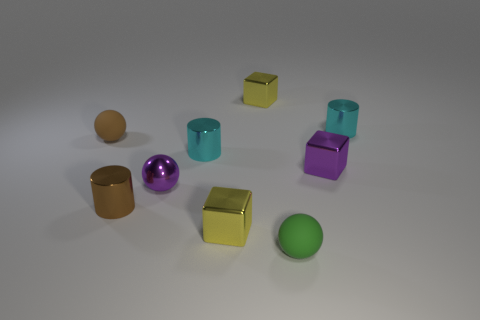What is the tiny sphere that is in front of the small yellow shiny object that is in front of the tiny brown ball made of?
Provide a short and direct response. Rubber. There is a small brown metallic cylinder; are there any metallic cylinders to the left of it?
Make the answer very short. No. Does the green rubber object have the same size as the sphere that is behind the tiny purple shiny sphere?
Your response must be concise. Yes. There is a metallic thing that is the same shape as the tiny green matte object; what size is it?
Offer a very short reply. Small. There is a cyan metallic thing behind the brown rubber sphere; is its size the same as the yellow metal thing in front of the brown cylinder?
Your response must be concise. Yes. What number of small things are either yellow cubes or purple spheres?
Offer a terse response. 3. How many tiny spheres are both to the left of the tiny brown shiny object and in front of the small brown matte sphere?
Your answer should be compact. 0. Is the material of the tiny brown sphere the same as the small yellow object that is behind the tiny brown matte ball?
Provide a short and direct response. No. What number of purple objects are balls or matte balls?
Your response must be concise. 1. Are there any cyan metallic objects of the same size as the purple block?
Make the answer very short. Yes. 